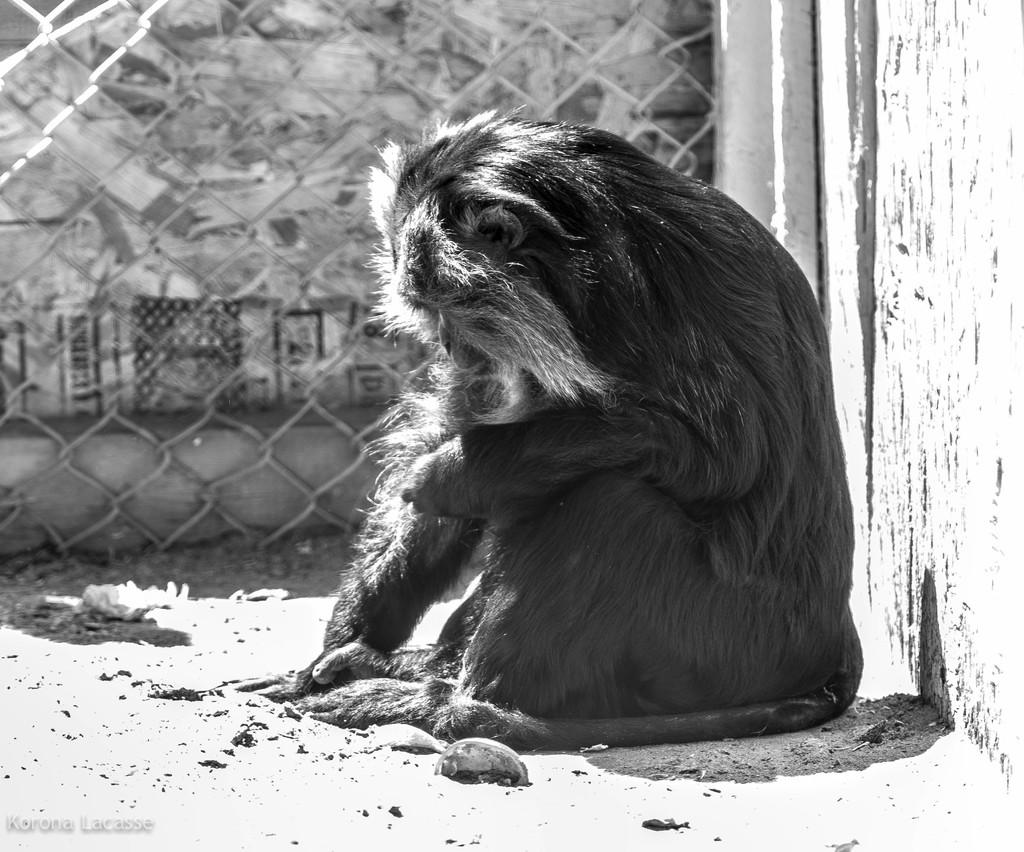What type of animal can be seen in the image? There is an animal in the image, but its specific type is not mentioned in the facts. What is the animal doing in the image? The animal is sitting on the ground. What can be seen in the background of the image? There is a mesh and a wall in the background of the image. What attraction is the animal visiting in the image? There is no indication of an attraction in the image; the animal is simply sitting on the ground. How many sons does the animal have in the image? There is no information about the animal's family or offspring in the image. 